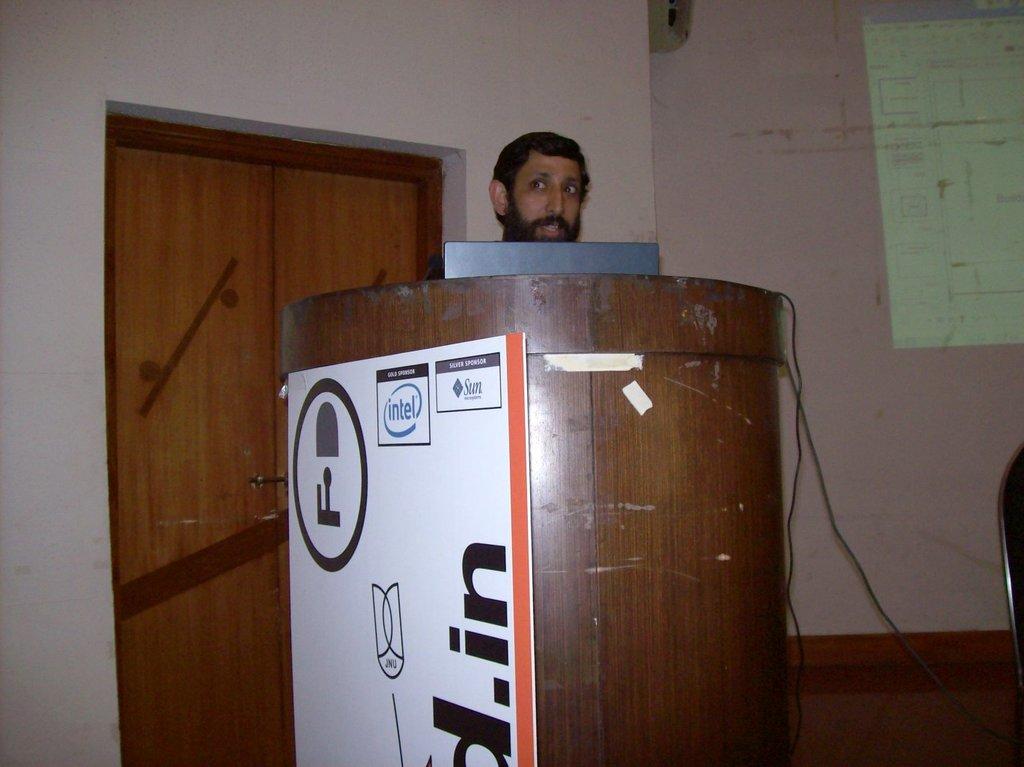What is advertised on the podium?
Your answer should be very brief. Intel. 